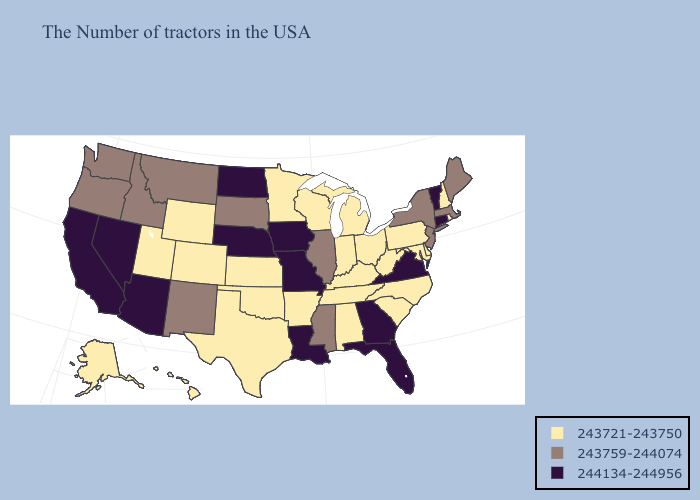Does South Dakota have the lowest value in the MidWest?
Give a very brief answer. No. What is the highest value in the South ?
Keep it brief. 244134-244956. What is the highest value in states that border New Mexico?
Concise answer only. 244134-244956. Does Maine have a lower value than Nevada?
Be succinct. Yes. What is the value of Maine?
Give a very brief answer. 243759-244074. Name the states that have a value in the range 243721-243750?
Write a very short answer. Rhode Island, New Hampshire, Delaware, Maryland, Pennsylvania, North Carolina, South Carolina, West Virginia, Ohio, Michigan, Kentucky, Indiana, Alabama, Tennessee, Wisconsin, Arkansas, Minnesota, Kansas, Oklahoma, Texas, Wyoming, Colorado, Utah, Alaska, Hawaii. Name the states that have a value in the range 243721-243750?
Concise answer only. Rhode Island, New Hampshire, Delaware, Maryland, Pennsylvania, North Carolina, South Carolina, West Virginia, Ohio, Michigan, Kentucky, Indiana, Alabama, Tennessee, Wisconsin, Arkansas, Minnesota, Kansas, Oklahoma, Texas, Wyoming, Colorado, Utah, Alaska, Hawaii. Name the states that have a value in the range 243759-244074?
Answer briefly. Maine, Massachusetts, New York, New Jersey, Illinois, Mississippi, South Dakota, New Mexico, Montana, Idaho, Washington, Oregon. Does the first symbol in the legend represent the smallest category?
Answer briefly. Yes. Name the states that have a value in the range 244134-244956?
Be succinct. Vermont, Connecticut, Virginia, Florida, Georgia, Louisiana, Missouri, Iowa, Nebraska, North Dakota, Arizona, Nevada, California. What is the lowest value in states that border Delaware?
Short answer required. 243721-243750. What is the highest value in the South ?
Answer briefly. 244134-244956. Among the states that border Rhode Island , does Massachusetts have the lowest value?
Write a very short answer. Yes. What is the value of Indiana?
Give a very brief answer. 243721-243750. Is the legend a continuous bar?
Quick response, please. No. 